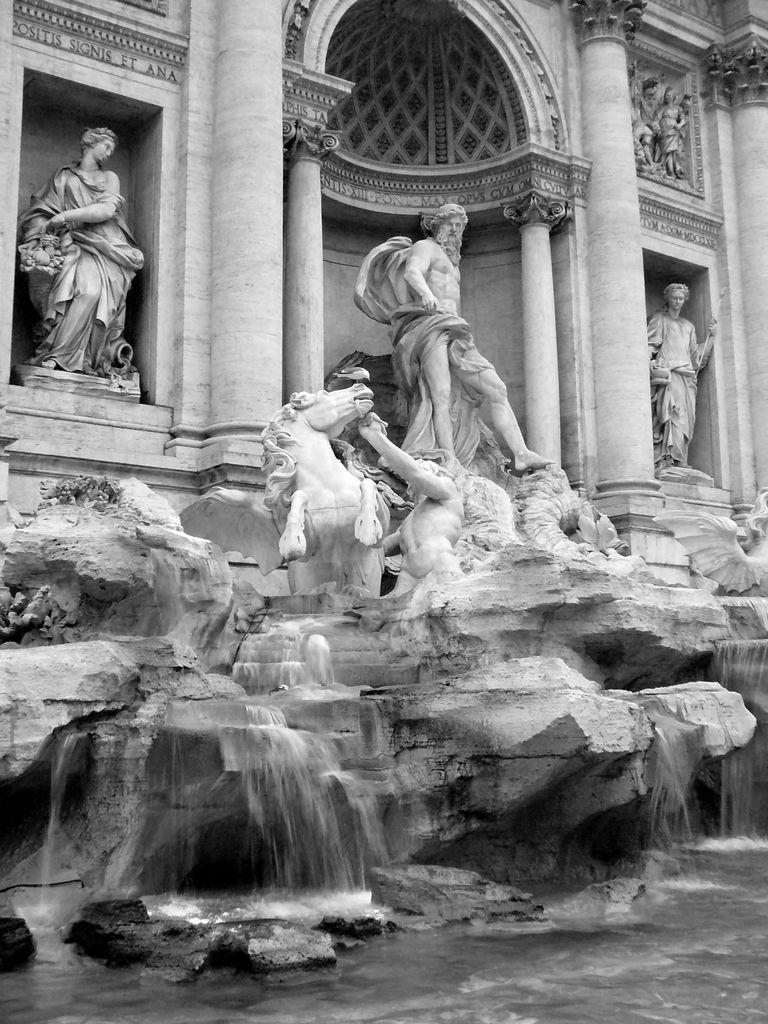What types of statues are present in the image? There are statues of human beings and a horse in the image. What can be seen in the background of the image? There is water visible in the image. What is the color scheme of the image? The image is black and white. What architectural features are present in the image? There are pillars in the image. Where is the hen located in the image? There is no hen present in the image. What type of lake can be seen in the image? There is no lake present in the image. 